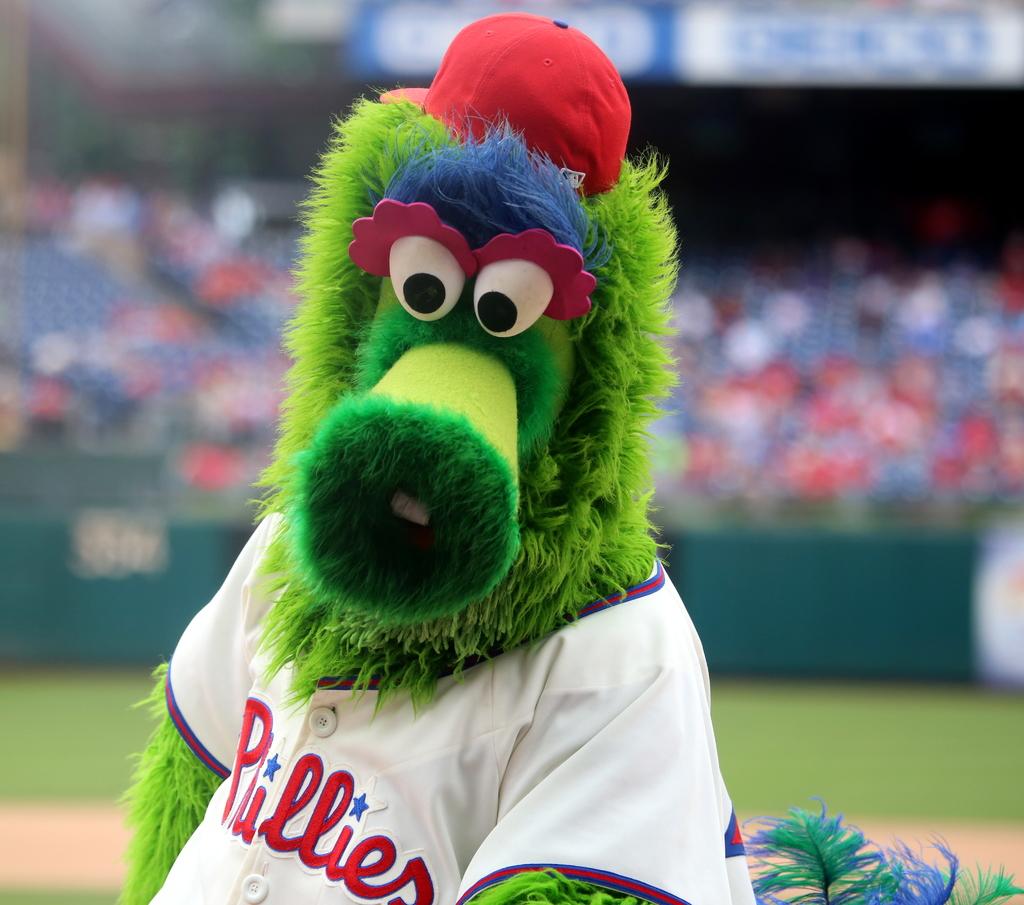What is the mascots team?
Offer a terse response. Phillies. 